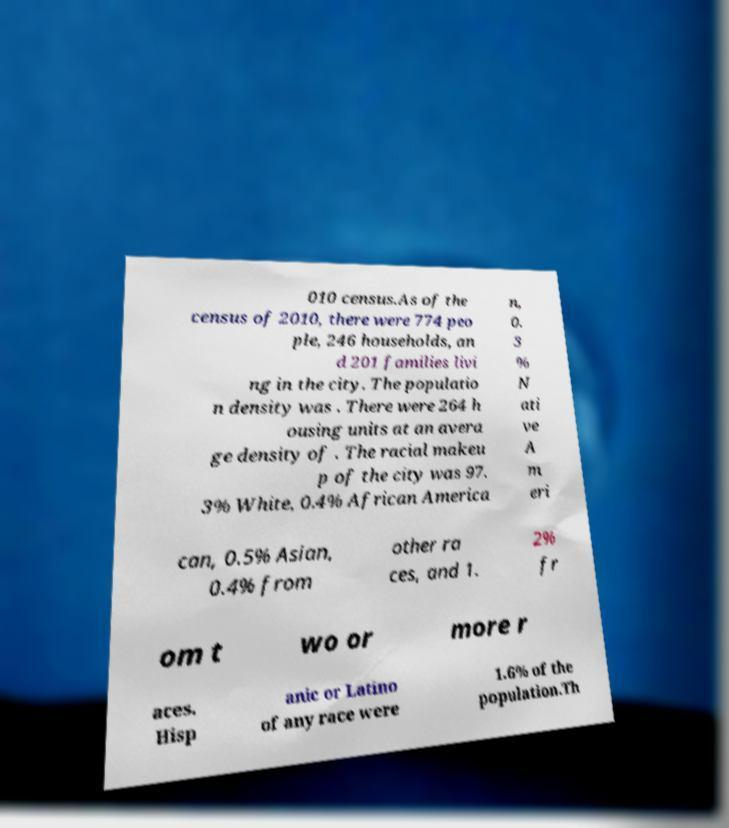For documentation purposes, I need the text within this image transcribed. Could you provide that? 010 census.As of the census of 2010, there were 774 peo ple, 246 households, an d 201 families livi ng in the city. The populatio n density was . There were 264 h ousing units at an avera ge density of . The racial makeu p of the city was 97. 3% White, 0.4% African America n, 0. 3 % N ati ve A m eri can, 0.5% Asian, 0.4% from other ra ces, and 1. 2% fr om t wo or more r aces. Hisp anic or Latino of any race were 1.6% of the population.Th 